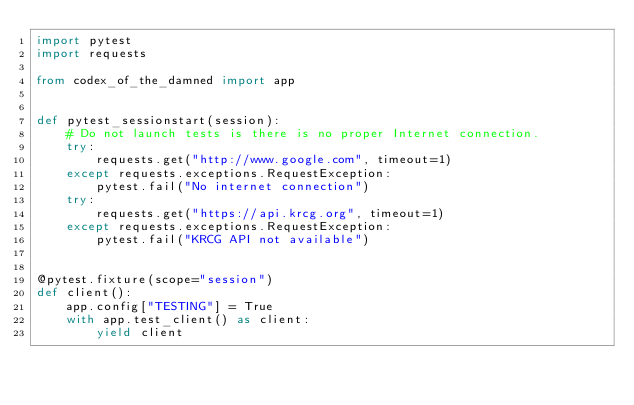Convert code to text. <code><loc_0><loc_0><loc_500><loc_500><_Python_>import pytest
import requests

from codex_of_the_damned import app


def pytest_sessionstart(session):
    # Do not launch tests is there is no proper Internet connection.
    try:
        requests.get("http://www.google.com", timeout=1)
    except requests.exceptions.RequestException:
        pytest.fail("No internet connection")
    try:
        requests.get("https://api.krcg.org", timeout=1)
    except requests.exceptions.RequestException:
        pytest.fail("KRCG API not available")


@pytest.fixture(scope="session")
def client():
    app.config["TESTING"] = True
    with app.test_client() as client:
        yield client
</code> 